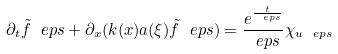Convert formula to latex. <formula><loc_0><loc_0><loc_500><loc_500>\partial _ { t } \tilde { f } ^ { \ } e p s + \partial _ { x } ( k ( x ) a ( \xi ) \tilde { f } ^ { \ } e p s ) = \frac { e ^ { \frac { t } { \ e p s } } } { \ e p s } \chi _ { u ^ { \ } e p s }</formula> 